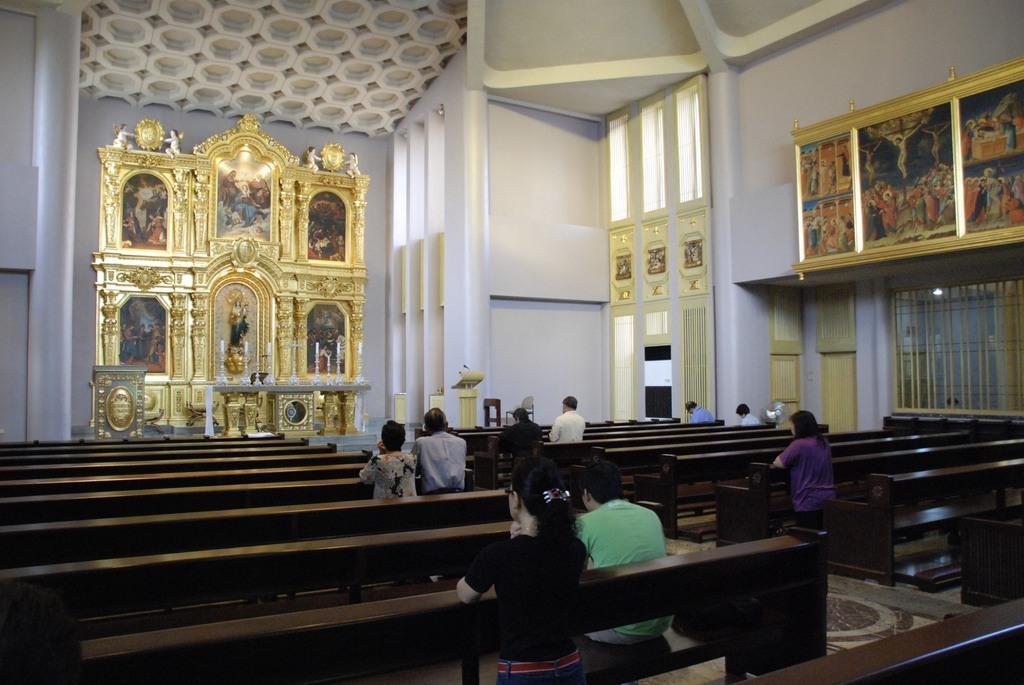Could you give a brief overview of what you see in this image? In this image there are benches, on the benches there are people sitting, in the background there is a wall for that wall there are photo frames, windows, doors, at the top there is a ceiling. 